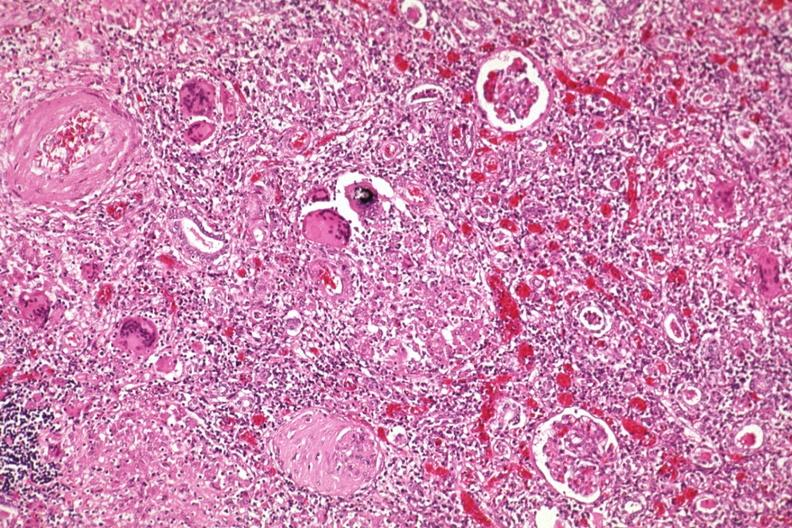where is this?
Answer the question using a single word or phrase. Urinary 